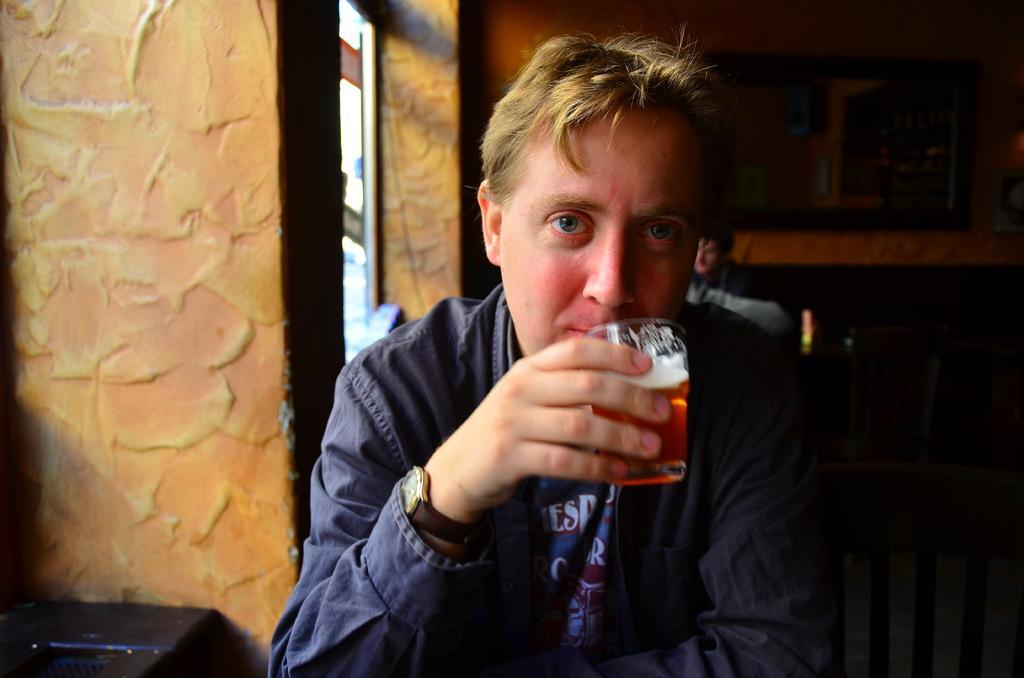Can you describe this image briefly? In this image I see a man who is wearing a blue shirt and he is holding a glass and there is a chair side to him. In the background I see the wall, a person and a table and another over here. 